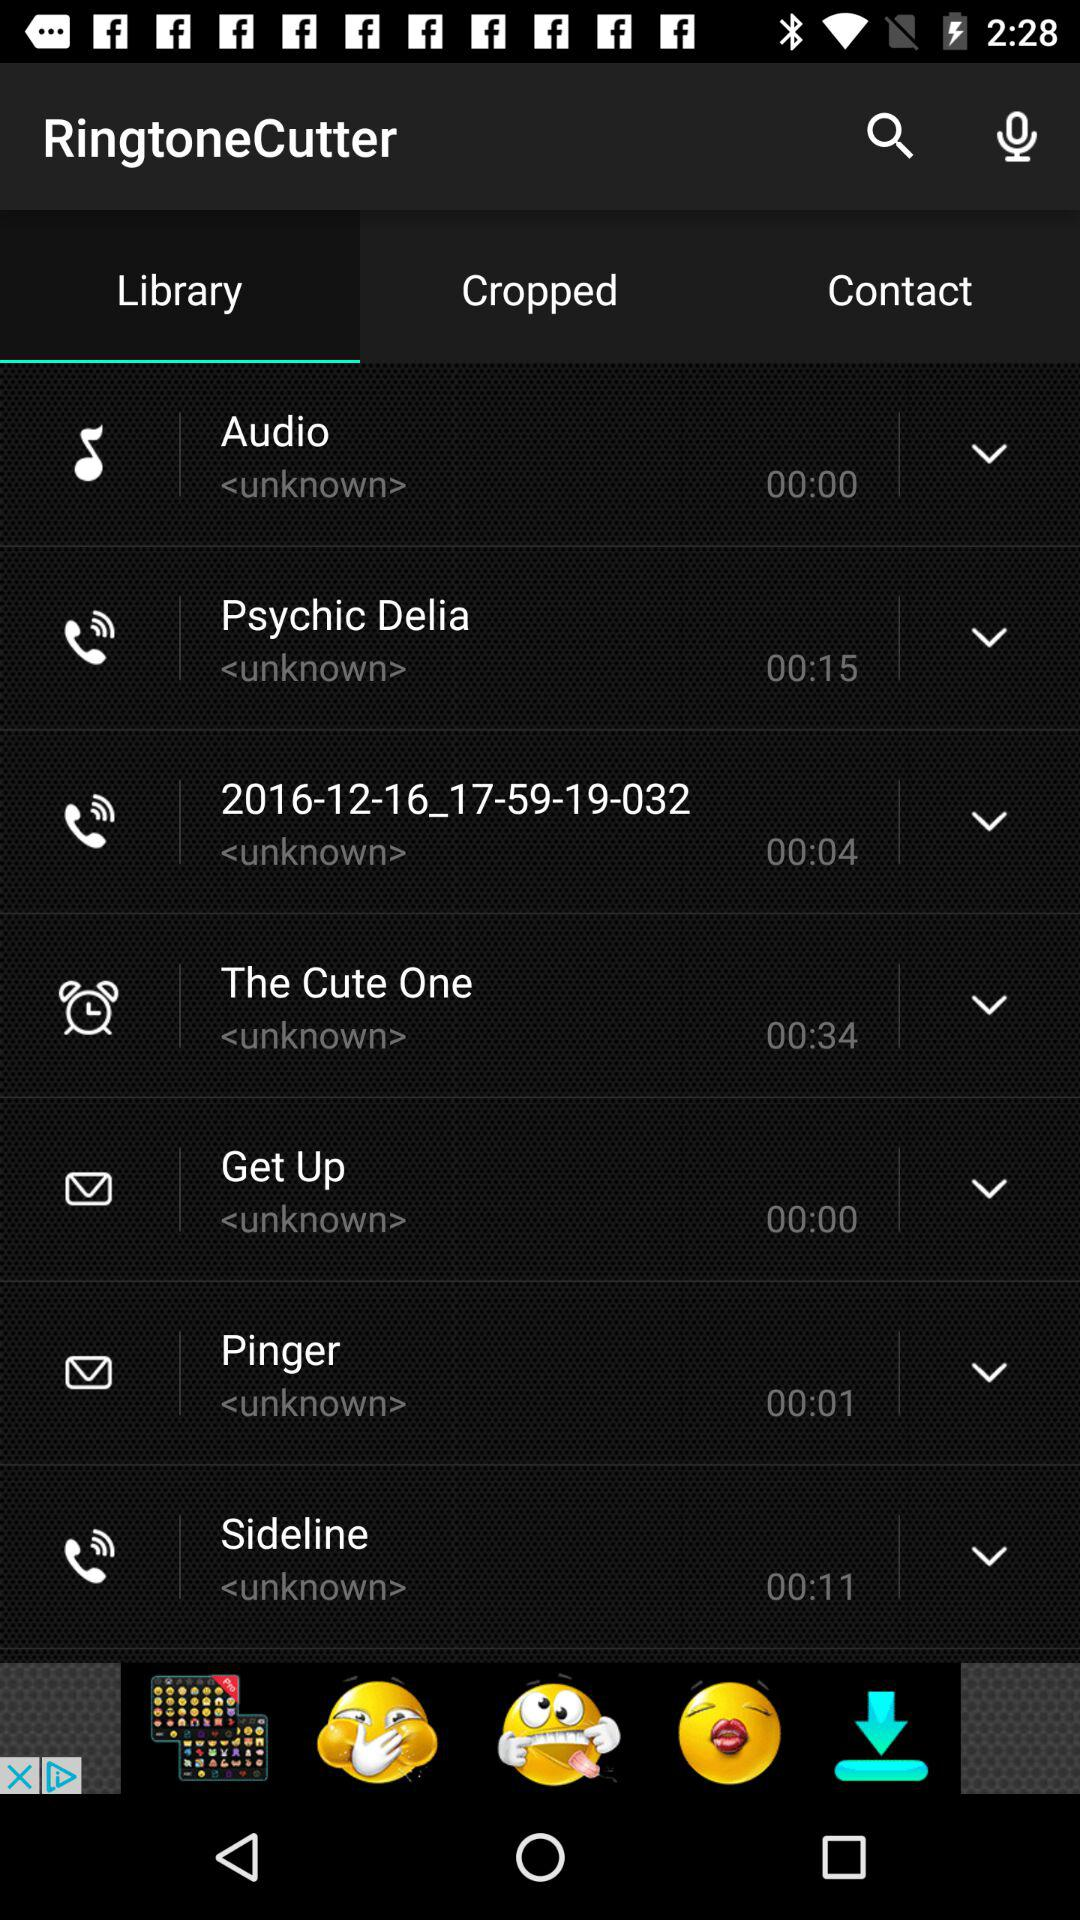What ringtone has a duration of 00:11 seconds? The ringtone is "Sideline". 